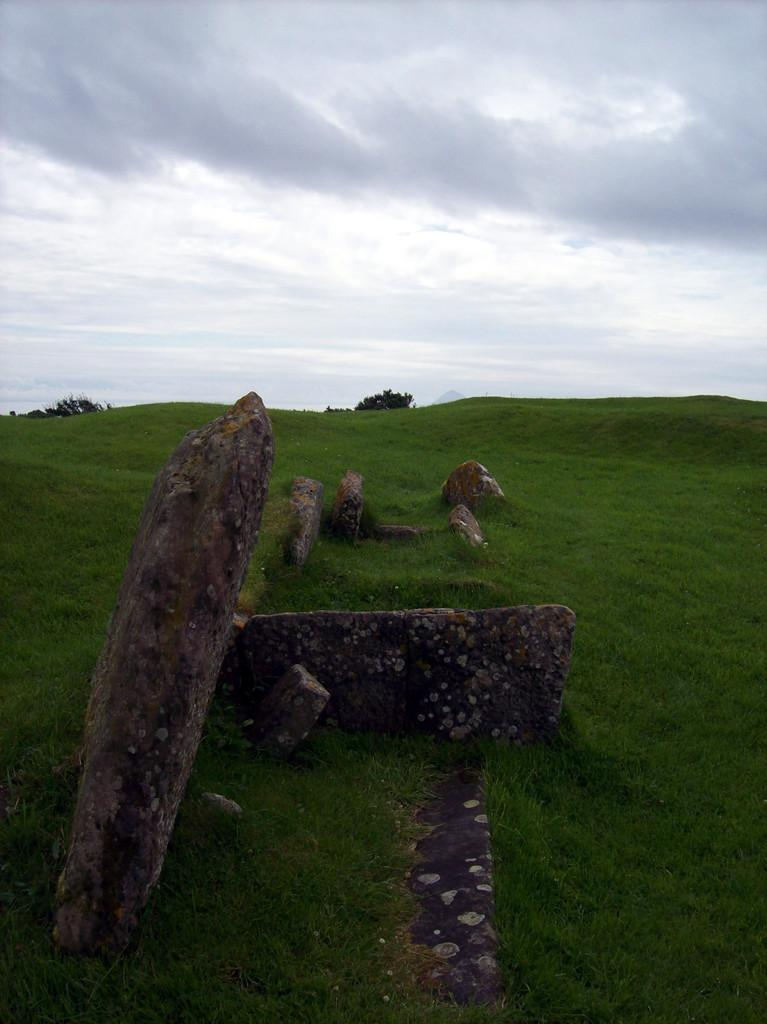What type of natural elements can be seen in the image? There are rocks, trees, and grass visible in the image. What part of the natural environment is not visible in the image? The image does not show any water elements, such as a river or lake. What is visible in the background of the image? The sky is visible in the image. What type of slave is depicted in the image? There is no slave depicted in the image; it features natural elements such as rocks, trees, and grass. What sound do the bells make in the image? There are no bells present in the image. 